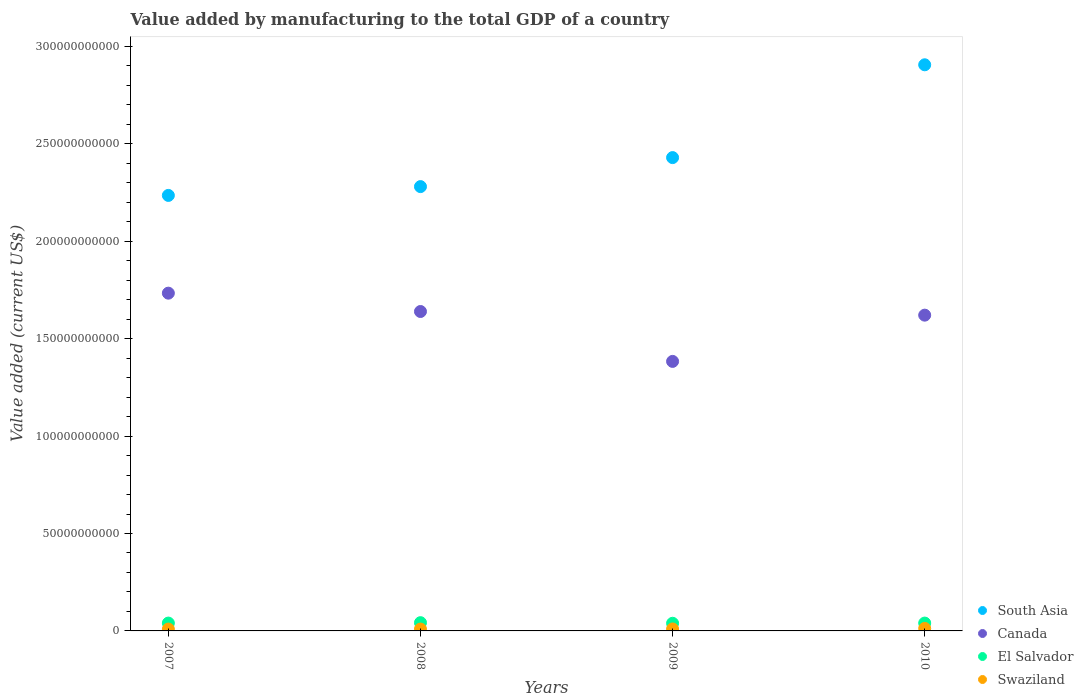How many different coloured dotlines are there?
Offer a very short reply. 4. What is the value added by manufacturing to the total GDP in El Salvador in 2007?
Your answer should be very brief. 4.03e+09. Across all years, what is the maximum value added by manufacturing to the total GDP in El Salvador?
Provide a succinct answer. 4.23e+09. Across all years, what is the minimum value added by manufacturing to the total GDP in Canada?
Make the answer very short. 1.38e+11. What is the total value added by manufacturing to the total GDP in El Salvador in the graph?
Ensure brevity in your answer.  1.62e+1. What is the difference between the value added by manufacturing to the total GDP in South Asia in 2007 and that in 2010?
Offer a terse response. -6.70e+1. What is the difference between the value added by manufacturing to the total GDP in El Salvador in 2010 and the value added by manufacturing to the total GDP in Canada in 2009?
Your answer should be compact. -1.34e+11. What is the average value added by manufacturing to the total GDP in South Asia per year?
Your answer should be compact. 2.46e+11. In the year 2010, what is the difference between the value added by manufacturing to the total GDP in Canada and value added by manufacturing to the total GDP in Swaziland?
Your response must be concise. 1.61e+11. What is the ratio of the value added by manufacturing to the total GDP in South Asia in 2007 to that in 2010?
Make the answer very short. 0.77. Is the value added by manufacturing to the total GDP in South Asia in 2007 less than that in 2010?
Your answer should be very brief. Yes. Is the difference between the value added by manufacturing to the total GDP in Canada in 2009 and 2010 greater than the difference between the value added by manufacturing to the total GDP in Swaziland in 2009 and 2010?
Your answer should be very brief. No. What is the difference between the highest and the second highest value added by manufacturing to the total GDP in Swaziland?
Offer a very short reply. 2.75e+08. What is the difference between the highest and the lowest value added by manufacturing to the total GDP in Swaziland?
Provide a succinct answer. 3.34e+08. In how many years, is the value added by manufacturing to the total GDP in South Asia greater than the average value added by manufacturing to the total GDP in South Asia taken over all years?
Offer a terse response. 1. Is the sum of the value added by manufacturing to the total GDP in El Salvador in 2007 and 2010 greater than the maximum value added by manufacturing to the total GDP in Swaziland across all years?
Provide a short and direct response. Yes. Is it the case that in every year, the sum of the value added by manufacturing to the total GDP in Canada and value added by manufacturing to the total GDP in Swaziland  is greater than the sum of value added by manufacturing to the total GDP in South Asia and value added by manufacturing to the total GDP in El Salvador?
Your answer should be very brief. Yes. Are the values on the major ticks of Y-axis written in scientific E-notation?
Your answer should be very brief. No. Does the graph contain any zero values?
Ensure brevity in your answer.  No. How many legend labels are there?
Make the answer very short. 4. How are the legend labels stacked?
Offer a very short reply. Vertical. What is the title of the graph?
Your response must be concise. Value added by manufacturing to the total GDP of a country. What is the label or title of the X-axis?
Offer a very short reply. Years. What is the label or title of the Y-axis?
Provide a short and direct response. Value added (current US$). What is the Value added (current US$) in South Asia in 2007?
Offer a terse response. 2.24e+11. What is the Value added (current US$) in Canada in 2007?
Your response must be concise. 1.73e+11. What is the Value added (current US$) in El Salvador in 2007?
Provide a succinct answer. 4.03e+09. What is the Value added (current US$) in Swaziland in 2007?
Offer a very short reply. 9.49e+08. What is the Value added (current US$) in South Asia in 2008?
Provide a short and direct response. 2.28e+11. What is the Value added (current US$) of Canada in 2008?
Your answer should be very brief. 1.64e+11. What is the Value added (current US$) of El Salvador in 2008?
Your response must be concise. 4.23e+09. What is the Value added (current US$) in Swaziland in 2008?
Your answer should be very brief. 9.46e+08. What is the Value added (current US$) in South Asia in 2009?
Keep it short and to the point. 2.43e+11. What is the Value added (current US$) in Canada in 2009?
Offer a very short reply. 1.38e+11. What is the Value added (current US$) of El Salvador in 2009?
Offer a very short reply. 3.92e+09. What is the Value added (current US$) in Swaziland in 2009?
Ensure brevity in your answer.  1.01e+09. What is the Value added (current US$) of South Asia in 2010?
Your response must be concise. 2.91e+11. What is the Value added (current US$) of Canada in 2010?
Give a very brief answer. 1.62e+11. What is the Value added (current US$) of El Salvador in 2010?
Your answer should be very brief. 4.03e+09. What is the Value added (current US$) of Swaziland in 2010?
Provide a short and direct response. 1.28e+09. Across all years, what is the maximum Value added (current US$) in South Asia?
Your answer should be compact. 2.91e+11. Across all years, what is the maximum Value added (current US$) in Canada?
Your answer should be very brief. 1.73e+11. Across all years, what is the maximum Value added (current US$) of El Salvador?
Keep it short and to the point. 4.23e+09. Across all years, what is the maximum Value added (current US$) of Swaziland?
Keep it short and to the point. 1.28e+09. Across all years, what is the minimum Value added (current US$) in South Asia?
Your answer should be compact. 2.24e+11. Across all years, what is the minimum Value added (current US$) of Canada?
Offer a terse response. 1.38e+11. Across all years, what is the minimum Value added (current US$) of El Salvador?
Provide a short and direct response. 3.92e+09. Across all years, what is the minimum Value added (current US$) in Swaziland?
Offer a terse response. 9.46e+08. What is the total Value added (current US$) in South Asia in the graph?
Ensure brevity in your answer.  9.85e+11. What is the total Value added (current US$) of Canada in the graph?
Make the answer very short. 6.38e+11. What is the total Value added (current US$) in El Salvador in the graph?
Offer a very short reply. 1.62e+1. What is the total Value added (current US$) in Swaziland in the graph?
Offer a terse response. 4.18e+09. What is the difference between the Value added (current US$) in South Asia in 2007 and that in 2008?
Your answer should be very brief. -4.52e+09. What is the difference between the Value added (current US$) in Canada in 2007 and that in 2008?
Provide a short and direct response. 9.42e+09. What is the difference between the Value added (current US$) in El Salvador in 2007 and that in 2008?
Make the answer very short. -2.08e+08. What is the difference between the Value added (current US$) in Swaziland in 2007 and that in 2008?
Keep it short and to the point. 2.89e+06. What is the difference between the Value added (current US$) in South Asia in 2007 and that in 2009?
Your answer should be very brief. -1.94e+1. What is the difference between the Value added (current US$) in Canada in 2007 and that in 2009?
Offer a very short reply. 3.50e+1. What is the difference between the Value added (current US$) of El Salvador in 2007 and that in 2009?
Provide a succinct answer. 1.01e+08. What is the difference between the Value added (current US$) in Swaziland in 2007 and that in 2009?
Keep it short and to the point. -5.64e+07. What is the difference between the Value added (current US$) in South Asia in 2007 and that in 2010?
Offer a very short reply. -6.70e+1. What is the difference between the Value added (current US$) of Canada in 2007 and that in 2010?
Your answer should be compact. 1.13e+1. What is the difference between the Value added (current US$) in El Salvador in 2007 and that in 2010?
Offer a terse response. -9.00e+05. What is the difference between the Value added (current US$) in Swaziland in 2007 and that in 2010?
Offer a terse response. -3.31e+08. What is the difference between the Value added (current US$) in South Asia in 2008 and that in 2009?
Provide a succinct answer. -1.49e+1. What is the difference between the Value added (current US$) of Canada in 2008 and that in 2009?
Ensure brevity in your answer.  2.56e+1. What is the difference between the Value added (current US$) in El Salvador in 2008 and that in 2009?
Your answer should be very brief. 3.09e+08. What is the difference between the Value added (current US$) in Swaziland in 2008 and that in 2009?
Offer a terse response. -5.93e+07. What is the difference between the Value added (current US$) in South Asia in 2008 and that in 2010?
Give a very brief answer. -6.25e+1. What is the difference between the Value added (current US$) in Canada in 2008 and that in 2010?
Provide a succinct answer. 1.87e+09. What is the difference between the Value added (current US$) in El Salvador in 2008 and that in 2010?
Make the answer very short. 2.07e+08. What is the difference between the Value added (current US$) in Swaziland in 2008 and that in 2010?
Keep it short and to the point. -3.34e+08. What is the difference between the Value added (current US$) in South Asia in 2009 and that in 2010?
Provide a succinct answer. -4.76e+1. What is the difference between the Value added (current US$) in Canada in 2009 and that in 2010?
Provide a succinct answer. -2.37e+1. What is the difference between the Value added (current US$) of El Salvador in 2009 and that in 2010?
Give a very brief answer. -1.02e+08. What is the difference between the Value added (current US$) in Swaziland in 2009 and that in 2010?
Provide a short and direct response. -2.75e+08. What is the difference between the Value added (current US$) of South Asia in 2007 and the Value added (current US$) of Canada in 2008?
Ensure brevity in your answer.  5.96e+1. What is the difference between the Value added (current US$) in South Asia in 2007 and the Value added (current US$) in El Salvador in 2008?
Provide a succinct answer. 2.19e+11. What is the difference between the Value added (current US$) of South Asia in 2007 and the Value added (current US$) of Swaziland in 2008?
Make the answer very short. 2.23e+11. What is the difference between the Value added (current US$) in Canada in 2007 and the Value added (current US$) in El Salvador in 2008?
Your answer should be very brief. 1.69e+11. What is the difference between the Value added (current US$) in Canada in 2007 and the Value added (current US$) in Swaziland in 2008?
Your answer should be compact. 1.72e+11. What is the difference between the Value added (current US$) in El Salvador in 2007 and the Value added (current US$) in Swaziland in 2008?
Your answer should be very brief. 3.08e+09. What is the difference between the Value added (current US$) in South Asia in 2007 and the Value added (current US$) in Canada in 2009?
Your response must be concise. 8.52e+1. What is the difference between the Value added (current US$) in South Asia in 2007 and the Value added (current US$) in El Salvador in 2009?
Offer a very short reply. 2.20e+11. What is the difference between the Value added (current US$) of South Asia in 2007 and the Value added (current US$) of Swaziland in 2009?
Offer a terse response. 2.23e+11. What is the difference between the Value added (current US$) of Canada in 2007 and the Value added (current US$) of El Salvador in 2009?
Give a very brief answer. 1.69e+11. What is the difference between the Value added (current US$) in Canada in 2007 and the Value added (current US$) in Swaziland in 2009?
Offer a very short reply. 1.72e+11. What is the difference between the Value added (current US$) of El Salvador in 2007 and the Value added (current US$) of Swaziland in 2009?
Make the answer very short. 3.02e+09. What is the difference between the Value added (current US$) in South Asia in 2007 and the Value added (current US$) in Canada in 2010?
Offer a terse response. 6.15e+1. What is the difference between the Value added (current US$) in South Asia in 2007 and the Value added (current US$) in El Salvador in 2010?
Your answer should be very brief. 2.20e+11. What is the difference between the Value added (current US$) of South Asia in 2007 and the Value added (current US$) of Swaziland in 2010?
Give a very brief answer. 2.22e+11. What is the difference between the Value added (current US$) of Canada in 2007 and the Value added (current US$) of El Salvador in 2010?
Provide a succinct answer. 1.69e+11. What is the difference between the Value added (current US$) in Canada in 2007 and the Value added (current US$) in Swaziland in 2010?
Your answer should be very brief. 1.72e+11. What is the difference between the Value added (current US$) in El Salvador in 2007 and the Value added (current US$) in Swaziland in 2010?
Your answer should be very brief. 2.75e+09. What is the difference between the Value added (current US$) in South Asia in 2008 and the Value added (current US$) in Canada in 2009?
Provide a succinct answer. 8.97e+1. What is the difference between the Value added (current US$) in South Asia in 2008 and the Value added (current US$) in El Salvador in 2009?
Your answer should be very brief. 2.24e+11. What is the difference between the Value added (current US$) in South Asia in 2008 and the Value added (current US$) in Swaziland in 2009?
Offer a terse response. 2.27e+11. What is the difference between the Value added (current US$) in Canada in 2008 and the Value added (current US$) in El Salvador in 2009?
Your response must be concise. 1.60e+11. What is the difference between the Value added (current US$) in Canada in 2008 and the Value added (current US$) in Swaziland in 2009?
Keep it short and to the point. 1.63e+11. What is the difference between the Value added (current US$) of El Salvador in 2008 and the Value added (current US$) of Swaziland in 2009?
Keep it short and to the point. 3.23e+09. What is the difference between the Value added (current US$) in South Asia in 2008 and the Value added (current US$) in Canada in 2010?
Your response must be concise. 6.60e+1. What is the difference between the Value added (current US$) of South Asia in 2008 and the Value added (current US$) of El Salvador in 2010?
Offer a terse response. 2.24e+11. What is the difference between the Value added (current US$) of South Asia in 2008 and the Value added (current US$) of Swaziland in 2010?
Make the answer very short. 2.27e+11. What is the difference between the Value added (current US$) in Canada in 2008 and the Value added (current US$) in El Salvador in 2010?
Offer a very short reply. 1.60e+11. What is the difference between the Value added (current US$) in Canada in 2008 and the Value added (current US$) in Swaziland in 2010?
Your response must be concise. 1.63e+11. What is the difference between the Value added (current US$) in El Salvador in 2008 and the Value added (current US$) in Swaziland in 2010?
Ensure brevity in your answer.  2.95e+09. What is the difference between the Value added (current US$) in South Asia in 2009 and the Value added (current US$) in Canada in 2010?
Give a very brief answer. 8.09e+1. What is the difference between the Value added (current US$) of South Asia in 2009 and the Value added (current US$) of El Salvador in 2010?
Ensure brevity in your answer.  2.39e+11. What is the difference between the Value added (current US$) in South Asia in 2009 and the Value added (current US$) in Swaziland in 2010?
Offer a terse response. 2.42e+11. What is the difference between the Value added (current US$) of Canada in 2009 and the Value added (current US$) of El Salvador in 2010?
Provide a succinct answer. 1.34e+11. What is the difference between the Value added (current US$) of Canada in 2009 and the Value added (current US$) of Swaziland in 2010?
Ensure brevity in your answer.  1.37e+11. What is the difference between the Value added (current US$) in El Salvador in 2009 and the Value added (current US$) in Swaziland in 2010?
Your answer should be very brief. 2.64e+09. What is the average Value added (current US$) in South Asia per year?
Offer a very short reply. 2.46e+11. What is the average Value added (current US$) of Canada per year?
Make the answer very short. 1.59e+11. What is the average Value added (current US$) of El Salvador per year?
Give a very brief answer. 4.05e+09. What is the average Value added (current US$) of Swaziland per year?
Offer a terse response. 1.05e+09. In the year 2007, what is the difference between the Value added (current US$) of South Asia and Value added (current US$) of Canada?
Provide a succinct answer. 5.02e+1. In the year 2007, what is the difference between the Value added (current US$) of South Asia and Value added (current US$) of El Salvador?
Provide a short and direct response. 2.20e+11. In the year 2007, what is the difference between the Value added (current US$) in South Asia and Value added (current US$) in Swaziland?
Keep it short and to the point. 2.23e+11. In the year 2007, what is the difference between the Value added (current US$) of Canada and Value added (current US$) of El Salvador?
Give a very brief answer. 1.69e+11. In the year 2007, what is the difference between the Value added (current US$) of Canada and Value added (current US$) of Swaziland?
Your response must be concise. 1.72e+11. In the year 2007, what is the difference between the Value added (current US$) of El Salvador and Value added (current US$) of Swaziland?
Your answer should be very brief. 3.08e+09. In the year 2008, what is the difference between the Value added (current US$) of South Asia and Value added (current US$) of Canada?
Ensure brevity in your answer.  6.41e+1. In the year 2008, what is the difference between the Value added (current US$) of South Asia and Value added (current US$) of El Salvador?
Make the answer very short. 2.24e+11. In the year 2008, what is the difference between the Value added (current US$) of South Asia and Value added (current US$) of Swaziland?
Give a very brief answer. 2.27e+11. In the year 2008, what is the difference between the Value added (current US$) in Canada and Value added (current US$) in El Salvador?
Give a very brief answer. 1.60e+11. In the year 2008, what is the difference between the Value added (current US$) of Canada and Value added (current US$) of Swaziland?
Keep it short and to the point. 1.63e+11. In the year 2008, what is the difference between the Value added (current US$) in El Salvador and Value added (current US$) in Swaziland?
Ensure brevity in your answer.  3.29e+09. In the year 2009, what is the difference between the Value added (current US$) of South Asia and Value added (current US$) of Canada?
Ensure brevity in your answer.  1.05e+11. In the year 2009, what is the difference between the Value added (current US$) in South Asia and Value added (current US$) in El Salvador?
Make the answer very short. 2.39e+11. In the year 2009, what is the difference between the Value added (current US$) in South Asia and Value added (current US$) in Swaziland?
Ensure brevity in your answer.  2.42e+11. In the year 2009, what is the difference between the Value added (current US$) in Canada and Value added (current US$) in El Salvador?
Make the answer very short. 1.34e+11. In the year 2009, what is the difference between the Value added (current US$) of Canada and Value added (current US$) of Swaziland?
Provide a short and direct response. 1.37e+11. In the year 2009, what is the difference between the Value added (current US$) in El Salvador and Value added (current US$) in Swaziland?
Your answer should be very brief. 2.92e+09. In the year 2010, what is the difference between the Value added (current US$) of South Asia and Value added (current US$) of Canada?
Offer a terse response. 1.29e+11. In the year 2010, what is the difference between the Value added (current US$) of South Asia and Value added (current US$) of El Salvador?
Ensure brevity in your answer.  2.87e+11. In the year 2010, what is the difference between the Value added (current US$) of South Asia and Value added (current US$) of Swaziland?
Ensure brevity in your answer.  2.89e+11. In the year 2010, what is the difference between the Value added (current US$) in Canada and Value added (current US$) in El Salvador?
Offer a terse response. 1.58e+11. In the year 2010, what is the difference between the Value added (current US$) of Canada and Value added (current US$) of Swaziland?
Provide a short and direct response. 1.61e+11. In the year 2010, what is the difference between the Value added (current US$) of El Salvador and Value added (current US$) of Swaziland?
Provide a short and direct response. 2.75e+09. What is the ratio of the Value added (current US$) in South Asia in 2007 to that in 2008?
Offer a very short reply. 0.98. What is the ratio of the Value added (current US$) in Canada in 2007 to that in 2008?
Keep it short and to the point. 1.06. What is the ratio of the Value added (current US$) in El Salvador in 2007 to that in 2008?
Ensure brevity in your answer.  0.95. What is the ratio of the Value added (current US$) in Swaziland in 2007 to that in 2008?
Provide a short and direct response. 1. What is the ratio of the Value added (current US$) in South Asia in 2007 to that in 2009?
Provide a short and direct response. 0.92. What is the ratio of the Value added (current US$) of Canada in 2007 to that in 2009?
Your answer should be very brief. 1.25. What is the ratio of the Value added (current US$) in El Salvador in 2007 to that in 2009?
Provide a short and direct response. 1.03. What is the ratio of the Value added (current US$) in Swaziland in 2007 to that in 2009?
Your answer should be compact. 0.94. What is the ratio of the Value added (current US$) in South Asia in 2007 to that in 2010?
Offer a very short reply. 0.77. What is the ratio of the Value added (current US$) in Canada in 2007 to that in 2010?
Keep it short and to the point. 1.07. What is the ratio of the Value added (current US$) of Swaziland in 2007 to that in 2010?
Make the answer very short. 0.74. What is the ratio of the Value added (current US$) in South Asia in 2008 to that in 2009?
Your response must be concise. 0.94. What is the ratio of the Value added (current US$) of Canada in 2008 to that in 2009?
Your answer should be compact. 1.19. What is the ratio of the Value added (current US$) in El Salvador in 2008 to that in 2009?
Offer a terse response. 1.08. What is the ratio of the Value added (current US$) in Swaziland in 2008 to that in 2009?
Ensure brevity in your answer.  0.94. What is the ratio of the Value added (current US$) in South Asia in 2008 to that in 2010?
Give a very brief answer. 0.78. What is the ratio of the Value added (current US$) in Canada in 2008 to that in 2010?
Provide a short and direct response. 1.01. What is the ratio of the Value added (current US$) in El Salvador in 2008 to that in 2010?
Provide a short and direct response. 1.05. What is the ratio of the Value added (current US$) in Swaziland in 2008 to that in 2010?
Offer a terse response. 0.74. What is the ratio of the Value added (current US$) in South Asia in 2009 to that in 2010?
Provide a succinct answer. 0.84. What is the ratio of the Value added (current US$) of Canada in 2009 to that in 2010?
Provide a succinct answer. 0.85. What is the ratio of the Value added (current US$) of El Salvador in 2009 to that in 2010?
Offer a terse response. 0.97. What is the ratio of the Value added (current US$) of Swaziland in 2009 to that in 2010?
Ensure brevity in your answer.  0.79. What is the difference between the highest and the second highest Value added (current US$) of South Asia?
Your response must be concise. 4.76e+1. What is the difference between the highest and the second highest Value added (current US$) of Canada?
Your answer should be compact. 9.42e+09. What is the difference between the highest and the second highest Value added (current US$) of El Salvador?
Give a very brief answer. 2.07e+08. What is the difference between the highest and the second highest Value added (current US$) of Swaziland?
Provide a short and direct response. 2.75e+08. What is the difference between the highest and the lowest Value added (current US$) of South Asia?
Your answer should be compact. 6.70e+1. What is the difference between the highest and the lowest Value added (current US$) of Canada?
Offer a terse response. 3.50e+1. What is the difference between the highest and the lowest Value added (current US$) in El Salvador?
Keep it short and to the point. 3.09e+08. What is the difference between the highest and the lowest Value added (current US$) of Swaziland?
Your answer should be compact. 3.34e+08. 